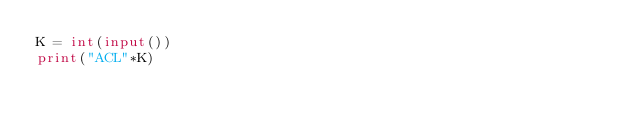<code> <loc_0><loc_0><loc_500><loc_500><_Python_>K = int(input())
print("ACL"*K)</code> 